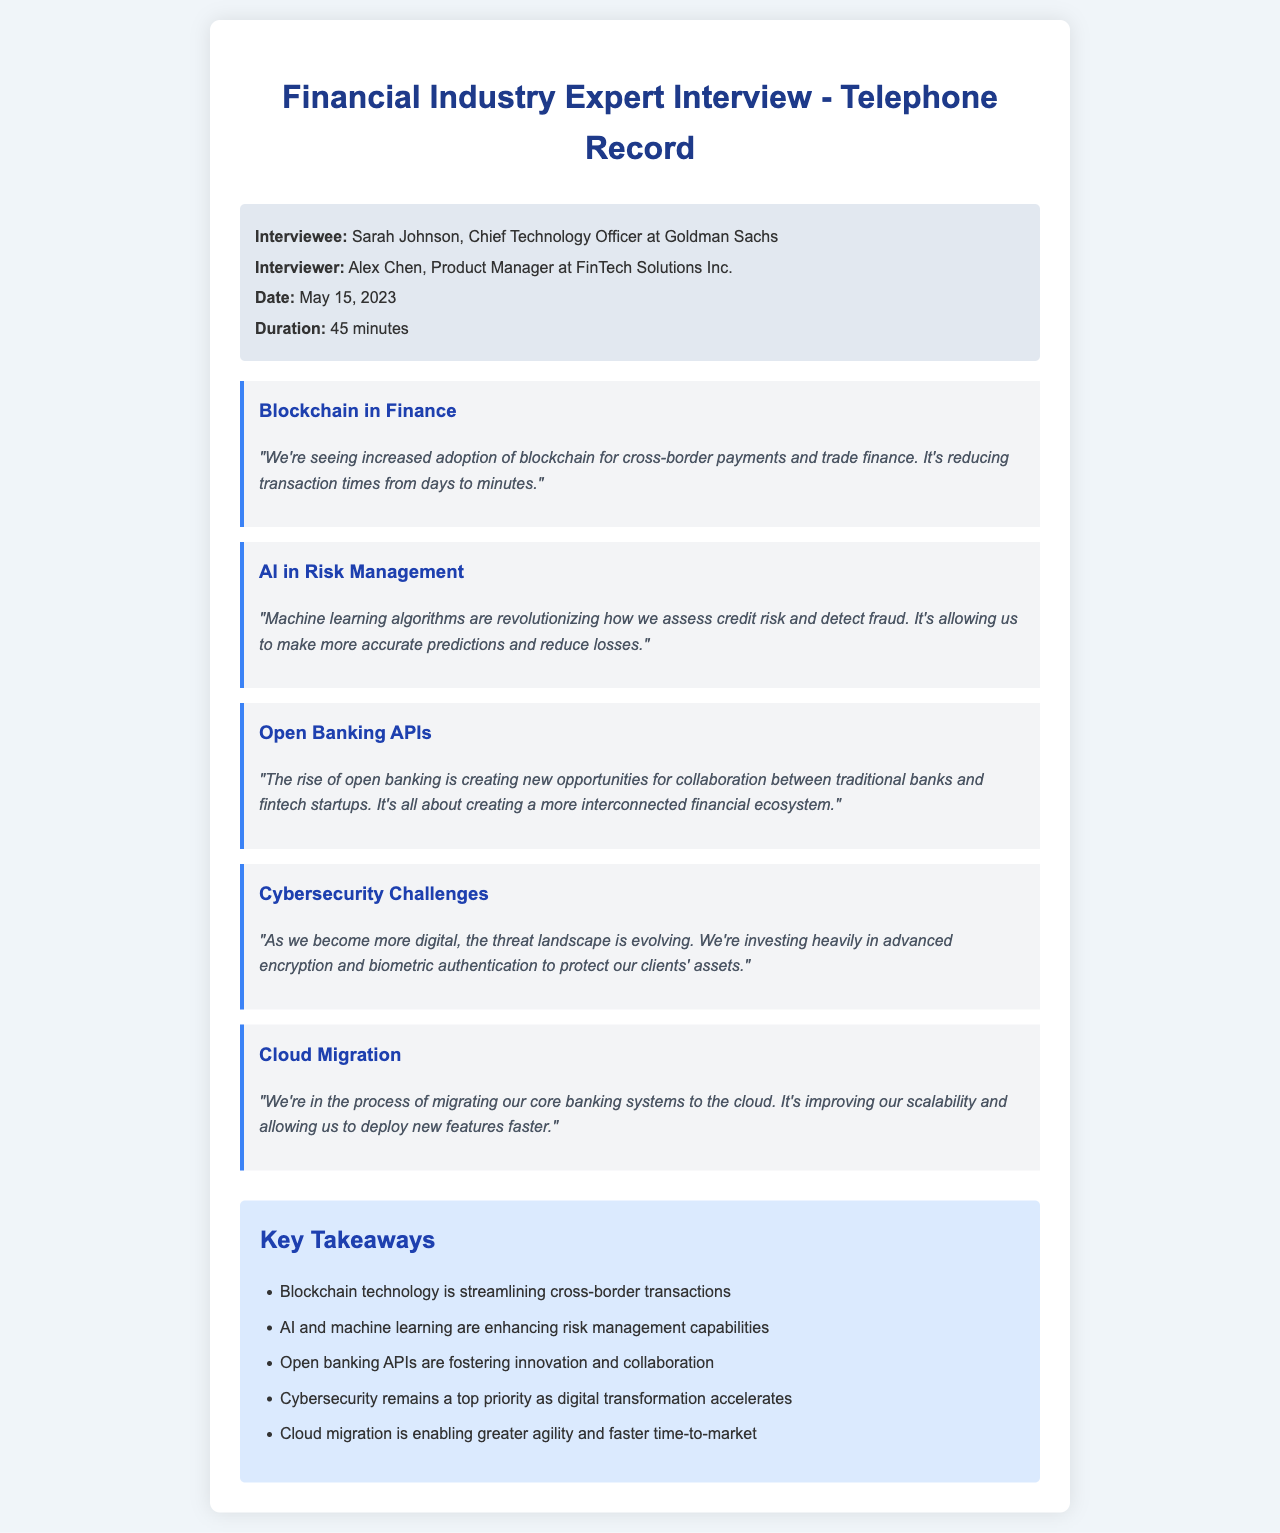What is the name of the interviewee? The interviewee is identified in the document as the Chief Technology Officer at Goldman Sachs.
Answer: Sarah Johnson Who conducted the interview? The document states that Alex Chen is the interviewer for this telephone record.
Answer: Alex Chen When did the interview take place? The date of the interview is explicitly mentioned in the document as May 15, 2023.
Answer: May 15, 2023 What is one technology mentioned for enhancing risk management? The interview highlights the use of machine learning algorithms for credit risk assessment and fraud detection.
Answer: Machine learning How is cloud migration impacting their operations? The document states that migrating to the cloud is improving scalability and faster deployment of new features.
Answer: Scalability What is a key priority mentioned in relation to digital transformation? The interview emphasizes that cybersecurity is a top priority as financial institutions become more digital.
Answer: Cybersecurity What advantage does blockchain provide in financial transactions? The interviewee notes that blockchain reduces transaction times significantly.
Answer: Reducing transaction times What type of partnerships are encouraged by open banking? The document mentions that open banking is creating opportunities for collaboration between banks and fintech startups.
Answer: Collaboration How long was the interview? The duration of the interview is specified in the document as 45 minutes.
Answer: 45 minutes 